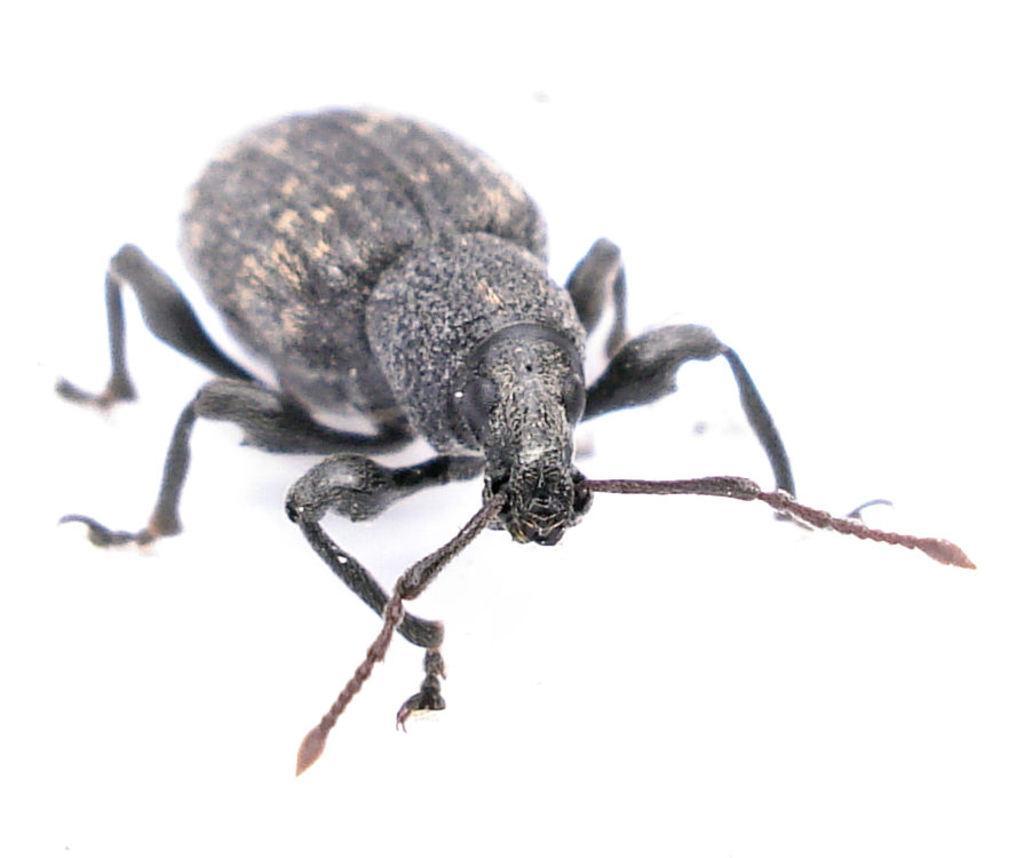How would you summarize this image in a sentence or two? In this image, we can see an insect on the white colored surface. 